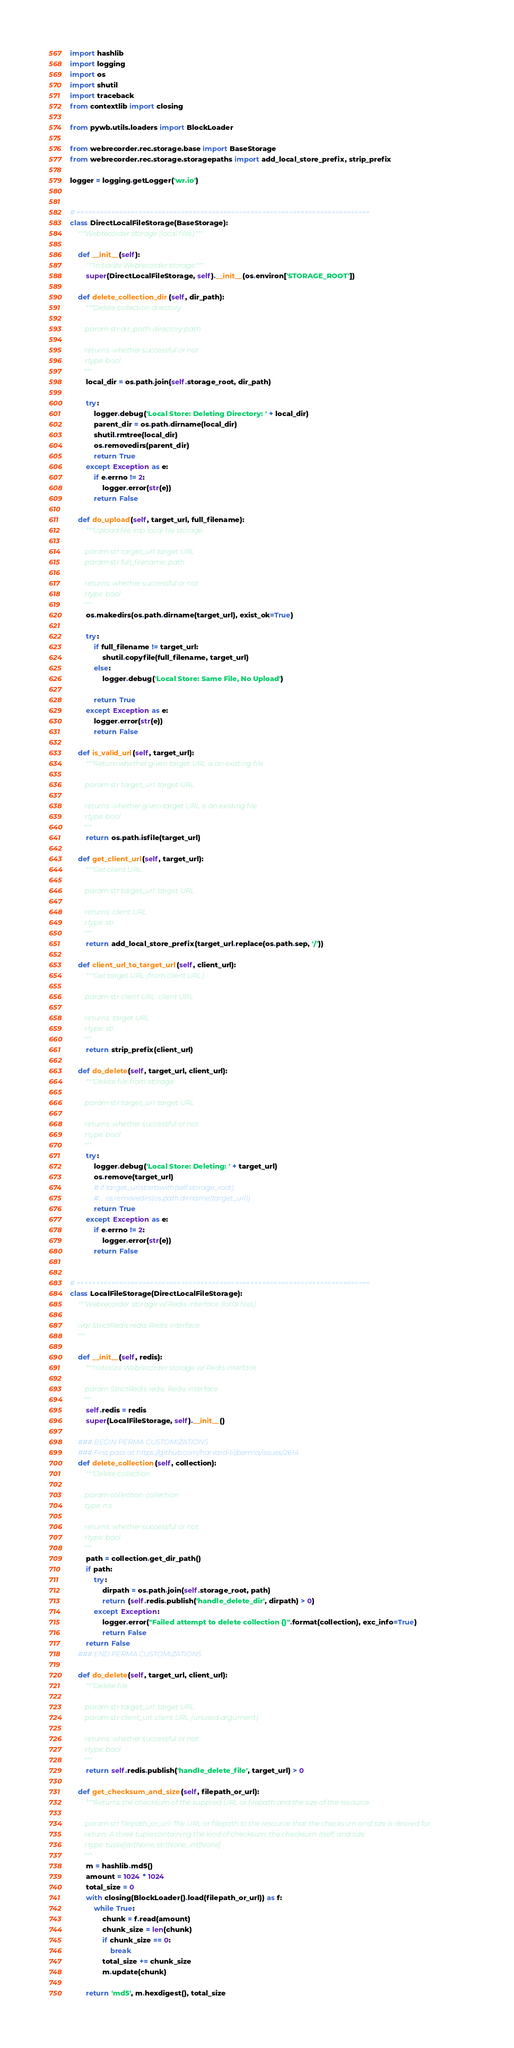<code> <loc_0><loc_0><loc_500><loc_500><_Python_>import hashlib
import logging
import os
import shutil
import traceback
from contextlib import closing

from pywb.utils.loaders import BlockLoader

from webrecorder.rec.storage.base import BaseStorage
from webrecorder.rec.storage.storagepaths import add_local_store_prefix, strip_prefix

logger = logging.getLogger('wr.io')


# ============================================================================
class DirectLocalFileStorage(BaseStorage):
    """Webrecorder storage (local files)."""

    def __init__(self):
        """Initialize Webrecorder storage."""
        super(DirectLocalFileStorage, self).__init__(os.environ['STORAGE_ROOT'])

    def delete_collection_dir(self, dir_path):
        """Delete collection directory.

        :param str dir_path: directory path

        :returns: whether successful or not
        :rtype: bool
        """
        local_dir = os.path.join(self.storage_root, dir_path)

        try:
            logger.debug('Local Store: Deleting Directory: ' + local_dir)
            parent_dir = os.path.dirname(local_dir)
            shutil.rmtree(local_dir)
            os.removedirs(parent_dir)
            return True
        except Exception as e:
            if e.errno != 2:
                logger.error(str(e))
            return False

    def do_upload(self, target_url, full_filename):
        """Upload file into local file storage.

        :param str target_url: target URL
        :param str full_filename: path

        :returns: whether successful or not
        :rtype: bool
        """
        os.makedirs(os.path.dirname(target_url), exist_ok=True)

        try:
            if full_filename != target_url:
                shutil.copyfile(full_filename, target_url)
            else:
                logger.debug('Local Store: Same File, No Upload')

            return True
        except Exception as e:
            logger.error(str(e))
            return False

    def is_valid_url(self, target_url):
        """Return whether given target URL is an existing file.

        :param str target_url: target URL

        :returns: whether given target URL is an existing file
        :rtype: bool
        """
        return os.path.isfile(target_url)

    def get_client_url(self, target_url):
        """Get client URL.

        :param str target_url: target URL

        :returns: client URL
        :rtype: str
        """
        return add_local_store_prefix(target_url.replace(os.path.sep, '/'))

    def client_url_to_target_url(self, client_url):
        """Get target URL (from client URL).

        :param str client URL: client URL

        :returns: target URL
        :rtype: str
        """
        return strip_prefix(client_url)

    def do_delete(self, target_url, client_url):
        """Delete file from storage.

        :param str target_url: target URL

        :returns: whether successful or not
        :rtype: bool
        """
        try:
            logger.debug('Local Store: Deleting: ' + target_url)
            os.remove(target_url)
            # if target_url.startswith(self.storage_root):
            #    os.removedirs(os.path.dirname(target_url))
            return True
        except Exception as e:
            if e.errno != 2:
                logger.error(str(e))
            return False


# ============================================================================
class LocalFileStorage(DirectLocalFileStorage):
    """Webrecorder storage w/ Redis interface (local files).

    :ivar StrictRedis redis: Redis interface
    """

    def __init__(self, redis):
        """Initialize Webrecorder storage w/ Redis interface.

        :param StrictRedis redis: Redis interface
        """
        self.redis = redis
        super(LocalFileStorage, self).__init__()

    ### BEGIN PERMA CUSTOMIZATIONS
    ### First pass at https://github.com/harvard-lil/perma/issues/2614
    def delete_collection(self, collection):
        """Delete collection.

        :param collection: collection
        :type: n.s.

        :returns: whether successful or not
        :rtype: bool
        """
        path = collection.get_dir_path()
        if path:
            try:
                dirpath = os.path.join(self.storage_root, path)
                return (self.redis.publish('handle_delete_dir', dirpath) > 0)
            except Exception:
                logger.error("Failed attempt to delete collection {}".format(collection), exc_info=True)
                return False
        return False
    ### END PERMA CUSTOMIZATIONS

    def do_delete(self, target_url, client_url):
        """Delete file.

        :param str target_url: target URL
        :param str client_url: client URL (unused argument)

        :returns: whether successful or not
        :rtype: bool
        """
        return self.redis.publish('handle_delete_file', target_url) > 0

    def get_checksum_and_size(self, filepath_or_url):
        """Returns the checksum of the supplied URL or filepath and the size of the resource

        :param str filepath_or_url: The URL or filepath to the resource that the checksum and size is desired for
        :return: A three tuple containing the kind of checksum, the checksum itself, and size
        :rtype: tuple[str|None, str|None, int|None]
        """
        m = hashlib.md5()
        amount = 1024 * 1024
        total_size = 0
        with closing(BlockLoader().load(filepath_or_url)) as f:
            while True:
                chunk = f.read(amount)
                chunk_size = len(chunk)
                if chunk_size == 0:
                    break
                total_size += chunk_size
                m.update(chunk)

        return 'md5', m.hexdigest(), total_size

</code> 